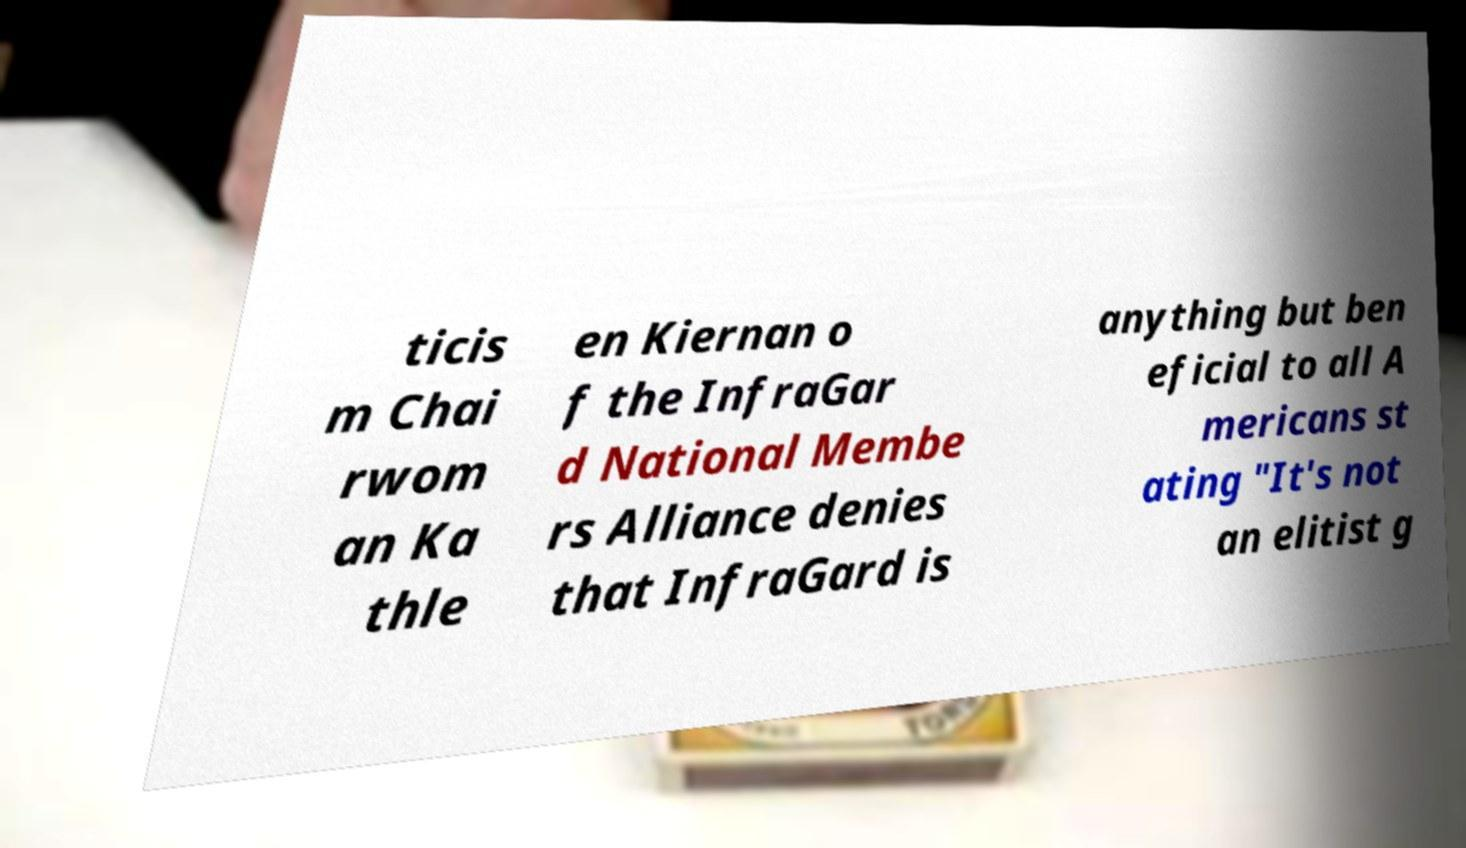Please read and relay the text visible in this image. What does it say? ticis m Chai rwom an Ka thle en Kiernan o f the InfraGar d National Membe rs Alliance denies that InfraGard is anything but ben eficial to all A mericans st ating "It's not an elitist g 